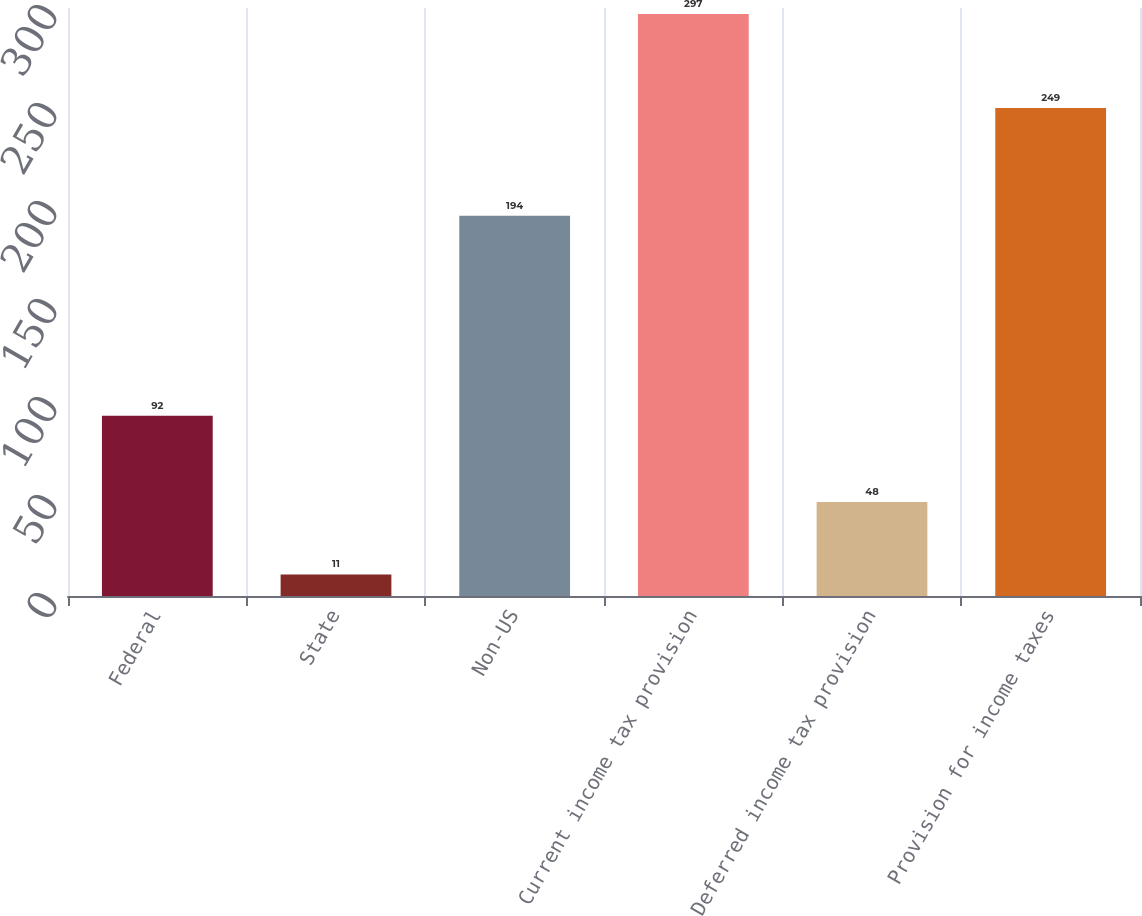Convert chart. <chart><loc_0><loc_0><loc_500><loc_500><bar_chart><fcel>Federal<fcel>State<fcel>Non-US<fcel>Current income tax provision<fcel>Deferred income tax provision<fcel>Provision for income taxes<nl><fcel>92<fcel>11<fcel>194<fcel>297<fcel>48<fcel>249<nl></chart> 